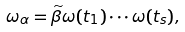<formula> <loc_0><loc_0><loc_500><loc_500>\omega _ { \alpha } = \widetilde { \beta } \omega ( t _ { 1 } ) \cdots \omega ( t _ { s } ) ,</formula> 